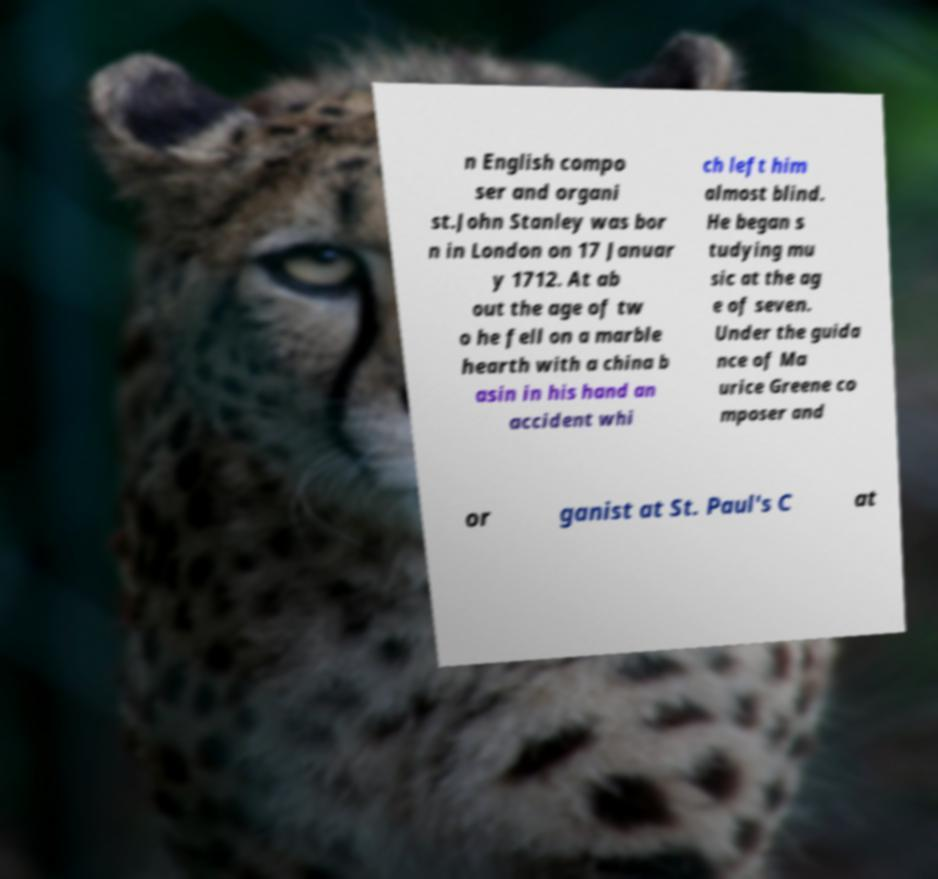Please read and relay the text visible in this image. What does it say? n English compo ser and organi st.John Stanley was bor n in London on 17 Januar y 1712. At ab out the age of tw o he fell on a marble hearth with a china b asin in his hand an accident whi ch left him almost blind. He began s tudying mu sic at the ag e of seven. Under the guida nce of Ma urice Greene co mposer and or ganist at St. Paul's C at 